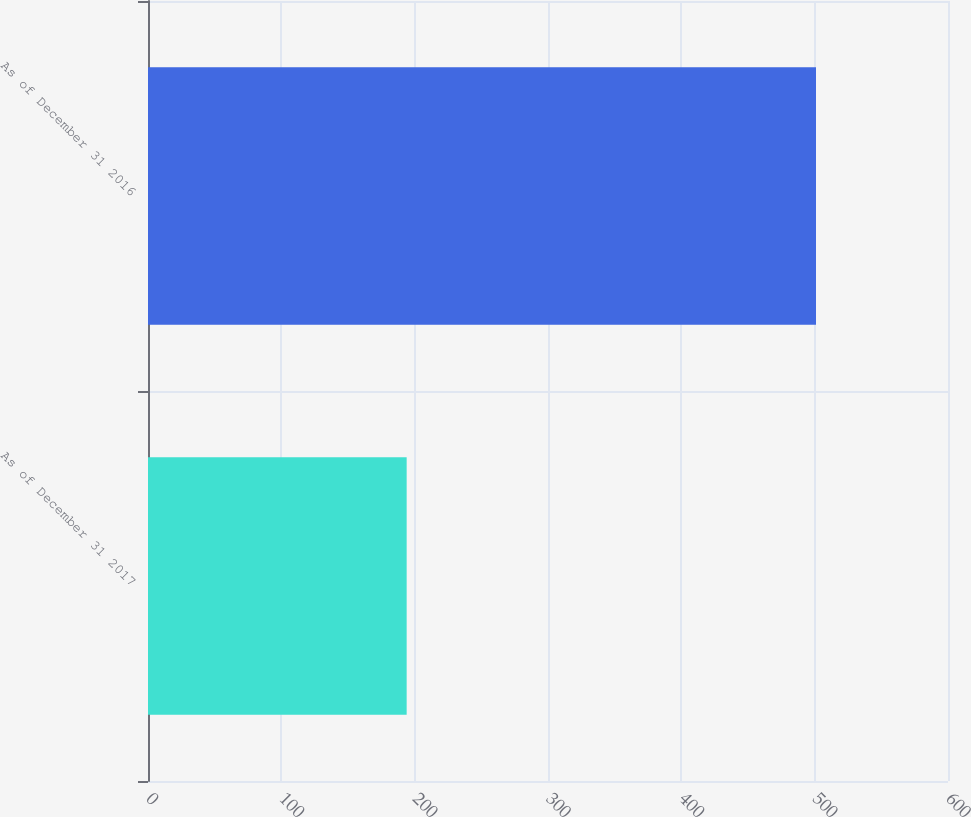Convert chart. <chart><loc_0><loc_0><loc_500><loc_500><bar_chart><fcel>As of December 31 2017<fcel>As of December 31 2016<nl><fcel>194<fcel>501<nl></chart> 